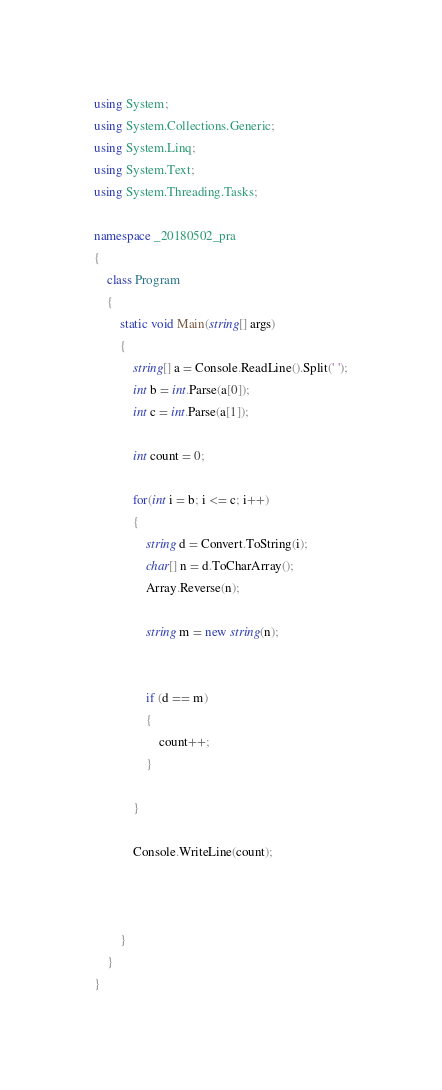Convert code to text. <code><loc_0><loc_0><loc_500><loc_500><_C#_>using System;
using System.Collections.Generic;
using System.Linq;
using System.Text;
using System.Threading.Tasks;

namespace _20180502_pra
{
    class Program
    {
        static void Main(string[] args)
        {
            string[] a = Console.ReadLine().Split(' ');
            int b = int.Parse(a[0]);
            int c = int.Parse(a[1]);

            int count = 0;

            for(int i = b; i <= c; i++)
            {
                string d = Convert.ToString(i);
                char[] n = d.ToCharArray();
                Array.Reverse(n);

                string m = new string(n);

               
                if (d == m)
                {
                    count++;
                }
               
            }

            Console.WriteLine(count);

            

        }
    }
}</code> 